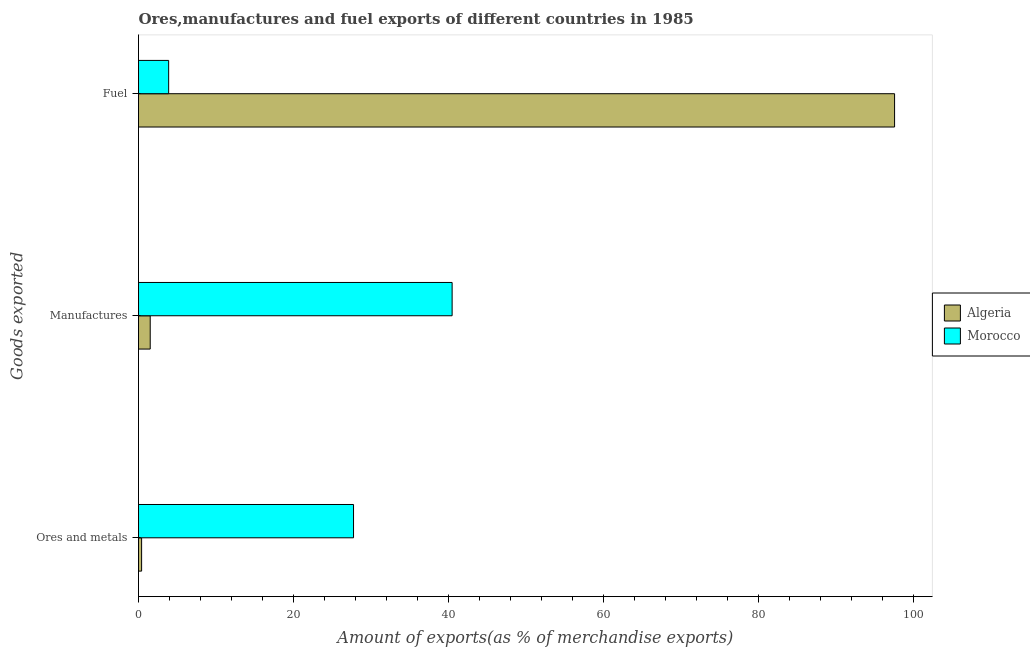How many different coloured bars are there?
Ensure brevity in your answer.  2. Are the number of bars per tick equal to the number of legend labels?
Your answer should be very brief. Yes. How many bars are there on the 2nd tick from the top?
Your response must be concise. 2. How many bars are there on the 1st tick from the bottom?
Offer a very short reply. 2. What is the label of the 1st group of bars from the top?
Provide a succinct answer. Fuel. What is the percentage of ores and metals exports in Morocco?
Make the answer very short. 27.73. Across all countries, what is the maximum percentage of manufactures exports?
Give a very brief answer. 40.45. Across all countries, what is the minimum percentage of manufactures exports?
Your answer should be compact. 1.51. In which country was the percentage of ores and metals exports maximum?
Keep it short and to the point. Morocco. In which country was the percentage of manufactures exports minimum?
Offer a very short reply. Algeria. What is the total percentage of fuel exports in the graph?
Provide a succinct answer. 101.41. What is the difference between the percentage of fuel exports in Algeria and that in Morocco?
Make the answer very short. 93.63. What is the difference between the percentage of ores and metals exports in Algeria and the percentage of manufactures exports in Morocco?
Make the answer very short. -40.05. What is the average percentage of manufactures exports per country?
Your answer should be very brief. 20.98. What is the difference between the percentage of ores and metals exports and percentage of fuel exports in Algeria?
Provide a short and direct response. -97.12. In how many countries, is the percentage of fuel exports greater than 64 %?
Provide a short and direct response. 1. What is the ratio of the percentage of manufactures exports in Algeria to that in Morocco?
Provide a short and direct response. 0.04. What is the difference between the highest and the second highest percentage of ores and metals exports?
Keep it short and to the point. 27.34. What is the difference between the highest and the lowest percentage of manufactures exports?
Your response must be concise. 38.94. In how many countries, is the percentage of ores and metals exports greater than the average percentage of ores and metals exports taken over all countries?
Your answer should be compact. 1. Is the sum of the percentage of ores and metals exports in Morocco and Algeria greater than the maximum percentage of fuel exports across all countries?
Make the answer very short. No. What does the 2nd bar from the top in Ores and metals represents?
Keep it short and to the point. Algeria. What does the 2nd bar from the bottom in Ores and metals represents?
Provide a short and direct response. Morocco. How many bars are there?
Make the answer very short. 6. Are all the bars in the graph horizontal?
Ensure brevity in your answer.  Yes. Are the values on the major ticks of X-axis written in scientific E-notation?
Ensure brevity in your answer.  No. How many legend labels are there?
Provide a short and direct response. 2. How are the legend labels stacked?
Your response must be concise. Vertical. What is the title of the graph?
Offer a terse response. Ores,manufactures and fuel exports of different countries in 1985. What is the label or title of the X-axis?
Your response must be concise. Amount of exports(as % of merchandise exports). What is the label or title of the Y-axis?
Make the answer very short. Goods exported. What is the Amount of exports(as % of merchandise exports) of Algeria in Ores and metals?
Make the answer very short. 0.4. What is the Amount of exports(as % of merchandise exports) of Morocco in Ores and metals?
Your response must be concise. 27.73. What is the Amount of exports(as % of merchandise exports) of Algeria in Manufactures?
Provide a short and direct response. 1.51. What is the Amount of exports(as % of merchandise exports) in Morocco in Manufactures?
Keep it short and to the point. 40.45. What is the Amount of exports(as % of merchandise exports) in Algeria in Fuel?
Keep it short and to the point. 97.52. What is the Amount of exports(as % of merchandise exports) of Morocco in Fuel?
Provide a short and direct response. 3.89. Across all Goods exported, what is the maximum Amount of exports(as % of merchandise exports) in Algeria?
Keep it short and to the point. 97.52. Across all Goods exported, what is the maximum Amount of exports(as % of merchandise exports) of Morocco?
Make the answer very short. 40.45. Across all Goods exported, what is the minimum Amount of exports(as % of merchandise exports) in Algeria?
Give a very brief answer. 0.4. Across all Goods exported, what is the minimum Amount of exports(as % of merchandise exports) in Morocco?
Your answer should be compact. 3.89. What is the total Amount of exports(as % of merchandise exports) of Algeria in the graph?
Your response must be concise. 99.43. What is the total Amount of exports(as % of merchandise exports) in Morocco in the graph?
Provide a short and direct response. 72.07. What is the difference between the Amount of exports(as % of merchandise exports) in Algeria in Ores and metals and that in Manufactures?
Ensure brevity in your answer.  -1.11. What is the difference between the Amount of exports(as % of merchandise exports) of Morocco in Ores and metals and that in Manufactures?
Your response must be concise. -12.72. What is the difference between the Amount of exports(as % of merchandise exports) of Algeria in Ores and metals and that in Fuel?
Offer a very short reply. -97.12. What is the difference between the Amount of exports(as % of merchandise exports) in Morocco in Ores and metals and that in Fuel?
Your response must be concise. 23.85. What is the difference between the Amount of exports(as % of merchandise exports) of Algeria in Manufactures and that in Fuel?
Ensure brevity in your answer.  -96.01. What is the difference between the Amount of exports(as % of merchandise exports) of Morocco in Manufactures and that in Fuel?
Your answer should be very brief. 36.56. What is the difference between the Amount of exports(as % of merchandise exports) in Algeria in Ores and metals and the Amount of exports(as % of merchandise exports) in Morocco in Manufactures?
Give a very brief answer. -40.05. What is the difference between the Amount of exports(as % of merchandise exports) of Algeria in Ores and metals and the Amount of exports(as % of merchandise exports) of Morocco in Fuel?
Provide a succinct answer. -3.49. What is the difference between the Amount of exports(as % of merchandise exports) of Algeria in Manufactures and the Amount of exports(as % of merchandise exports) of Morocco in Fuel?
Your response must be concise. -2.38. What is the average Amount of exports(as % of merchandise exports) of Algeria per Goods exported?
Ensure brevity in your answer.  33.14. What is the average Amount of exports(as % of merchandise exports) in Morocco per Goods exported?
Offer a very short reply. 24.02. What is the difference between the Amount of exports(as % of merchandise exports) in Algeria and Amount of exports(as % of merchandise exports) in Morocco in Ores and metals?
Keep it short and to the point. -27.34. What is the difference between the Amount of exports(as % of merchandise exports) in Algeria and Amount of exports(as % of merchandise exports) in Morocco in Manufactures?
Give a very brief answer. -38.94. What is the difference between the Amount of exports(as % of merchandise exports) of Algeria and Amount of exports(as % of merchandise exports) of Morocco in Fuel?
Give a very brief answer. 93.63. What is the ratio of the Amount of exports(as % of merchandise exports) of Algeria in Ores and metals to that in Manufactures?
Provide a short and direct response. 0.26. What is the ratio of the Amount of exports(as % of merchandise exports) in Morocco in Ores and metals to that in Manufactures?
Give a very brief answer. 0.69. What is the ratio of the Amount of exports(as % of merchandise exports) in Algeria in Ores and metals to that in Fuel?
Give a very brief answer. 0. What is the ratio of the Amount of exports(as % of merchandise exports) of Morocco in Ores and metals to that in Fuel?
Provide a succinct answer. 7.13. What is the ratio of the Amount of exports(as % of merchandise exports) in Algeria in Manufactures to that in Fuel?
Your answer should be very brief. 0.02. What is the ratio of the Amount of exports(as % of merchandise exports) in Morocco in Manufactures to that in Fuel?
Offer a very short reply. 10.4. What is the difference between the highest and the second highest Amount of exports(as % of merchandise exports) of Algeria?
Provide a succinct answer. 96.01. What is the difference between the highest and the second highest Amount of exports(as % of merchandise exports) of Morocco?
Make the answer very short. 12.72. What is the difference between the highest and the lowest Amount of exports(as % of merchandise exports) in Algeria?
Ensure brevity in your answer.  97.12. What is the difference between the highest and the lowest Amount of exports(as % of merchandise exports) in Morocco?
Provide a short and direct response. 36.56. 